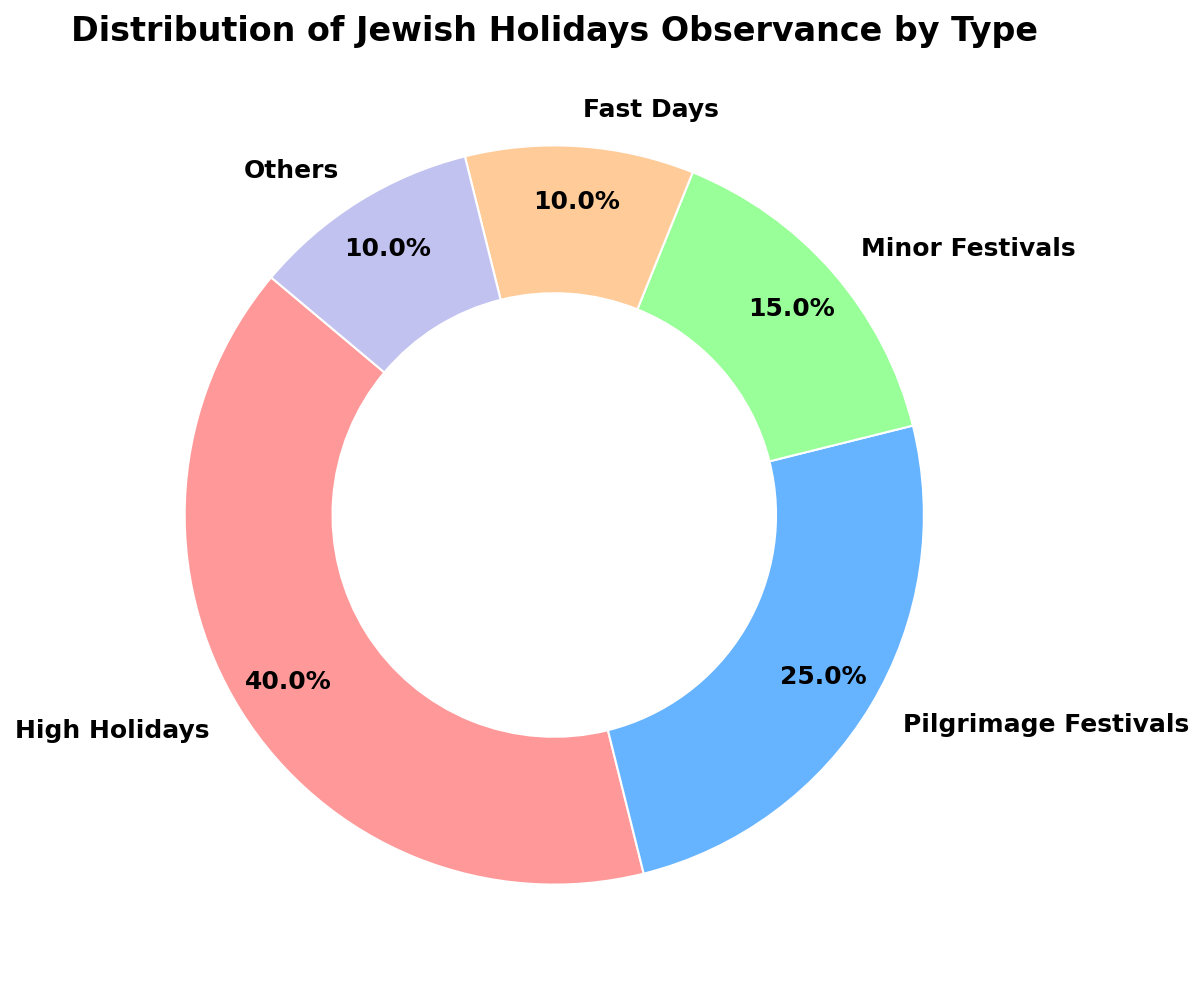Which category has the highest observance percentage? Observance is represented visually by the size of the wedges. The largest wedge corresponds to the "High Holidays" category. The label indicates it represents 40% of the total.
Answer: High Holidays Which two categories together form the smallest observance percentage? By looking at the wedges, the "Fast Days" and "Others" categories appear to be the smallest. Each of these is labelled with a 10% observance rate. Combined, they form 20%.
Answer: Fast Days and Others What percentage of Jewish holidays observance does not belong to the High Holidays category? Subtract the High Holidays percentage (40%) from 100% to get the remainder. 100% - 40% = 60%.
Answer: 60% How much larger is the 'High Holidays' observance compared to 'Pilgrimage Festivals'? The High Holidays have an observance of 40%, and the Pilgrimage Festivals have 25%. Subtract 25% from 40% to find the difference. 40% - 25% = 15%.
Answer: 15% What is the total percentage of observance for Minor Festivals and Fast Days combined? Sum the percentages of Minor Festivals (15%) and Fast Days (10%). 15% + 10% = 25%.
Answer: 25% What is the average percentage of observance for categories other than 'High Holidays'? Add the observance percentages for Pilgrimage Festivals (25%), Minor Festivals (15%), Fast Days (10%), and Others (10%), and then divide by 4. (25% + 15% + 10% + 10%) / 4 = 60% / 4 = 15%.
Answer: 15% What color represents the Pilgrimage Festivals category in the chart? Visually, the Pilgrimage Festivals section is the second wedge in a blue-like color.
Answer: Blue Are Minor Festivals observed more frequently than Fast Days? Compare the percentages given for each category. Minor Festivals are at 15%, while Fast Days are at 10%. 15% > 10%.
Answer: Yes Which category other than 'High Holidays' makes up the largest portion of observances? Observing the remaining wedges, Pilgrimage Festivals have a 25% observance, which is larger than other categories apart from High Holidays.
Answer: Pilgrimage Festivals If the total observance of categories excluding “Others” equals to 90%, what percentage does “Others” represent? Since “Others” is already provided 10% directly from the data, it confirms the calculation. Observance of "Others" is already given as 10%.
Answer: 10% 